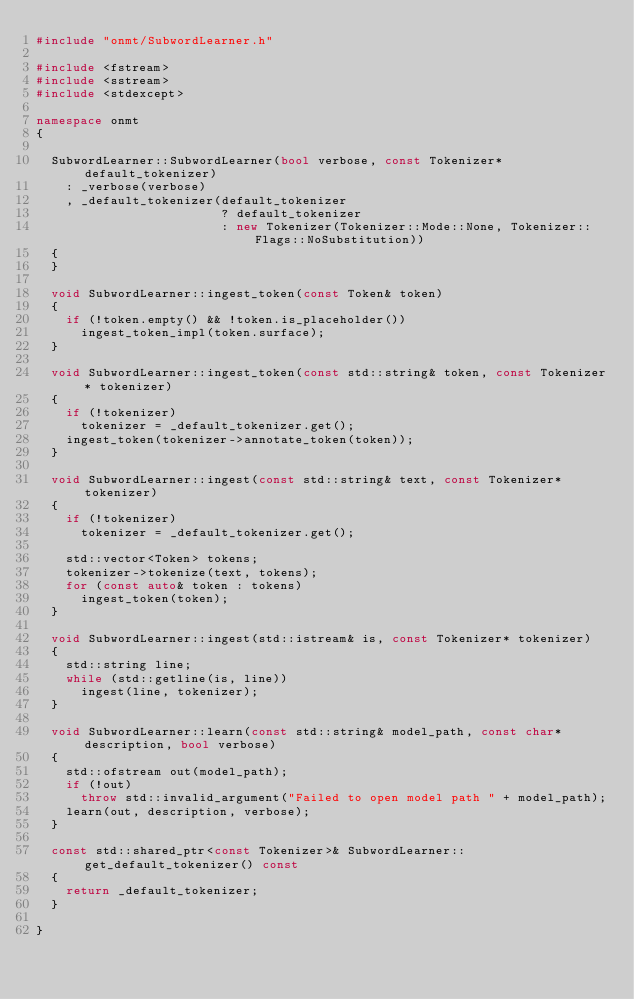<code> <loc_0><loc_0><loc_500><loc_500><_C++_>#include "onmt/SubwordLearner.h"

#include <fstream>
#include <sstream>
#include <stdexcept>

namespace onmt
{

  SubwordLearner::SubwordLearner(bool verbose, const Tokenizer* default_tokenizer)
    : _verbose(verbose)
    , _default_tokenizer(default_tokenizer
                         ? default_tokenizer
                         : new Tokenizer(Tokenizer::Mode::None, Tokenizer::Flags::NoSubstitution))
  {
  }

  void SubwordLearner::ingest_token(const Token& token)
  {
    if (!token.empty() && !token.is_placeholder())
      ingest_token_impl(token.surface);
  }

  void SubwordLearner::ingest_token(const std::string& token, const Tokenizer* tokenizer)
  {
    if (!tokenizer)
      tokenizer = _default_tokenizer.get();
    ingest_token(tokenizer->annotate_token(token));
  }

  void SubwordLearner::ingest(const std::string& text, const Tokenizer* tokenizer)
  {
    if (!tokenizer)
      tokenizer = _default_tokenizer.get();

    std::vector<Token> tokens;
    tokenizer->tokenize(text, tokens);
    for (const auto& token : tokens)
      ingest_token(token);
  }

  void SubwordLearner::ingest(std::istream& is, const Tokenizer* tokenizer)
  {
    std::string line;
    while (std::getline(is, line))
      ingest(line, tokenizer);
  }

  void SubwordLearner::learn(const std::string& model_path, const char* description, bool verbose)
  {
    std::ofstream out(model_path);
    if (!out)
      throw std::invalid_argument("Failed to open model path " + model_path);
    learn(out, description, verbose);
  }

  const std::shared_ptr<const Tokenizer>& SubwordLearner::get_default_tokenizer() const
  {
    return _default_tokenizer;
  }

}
</code> 